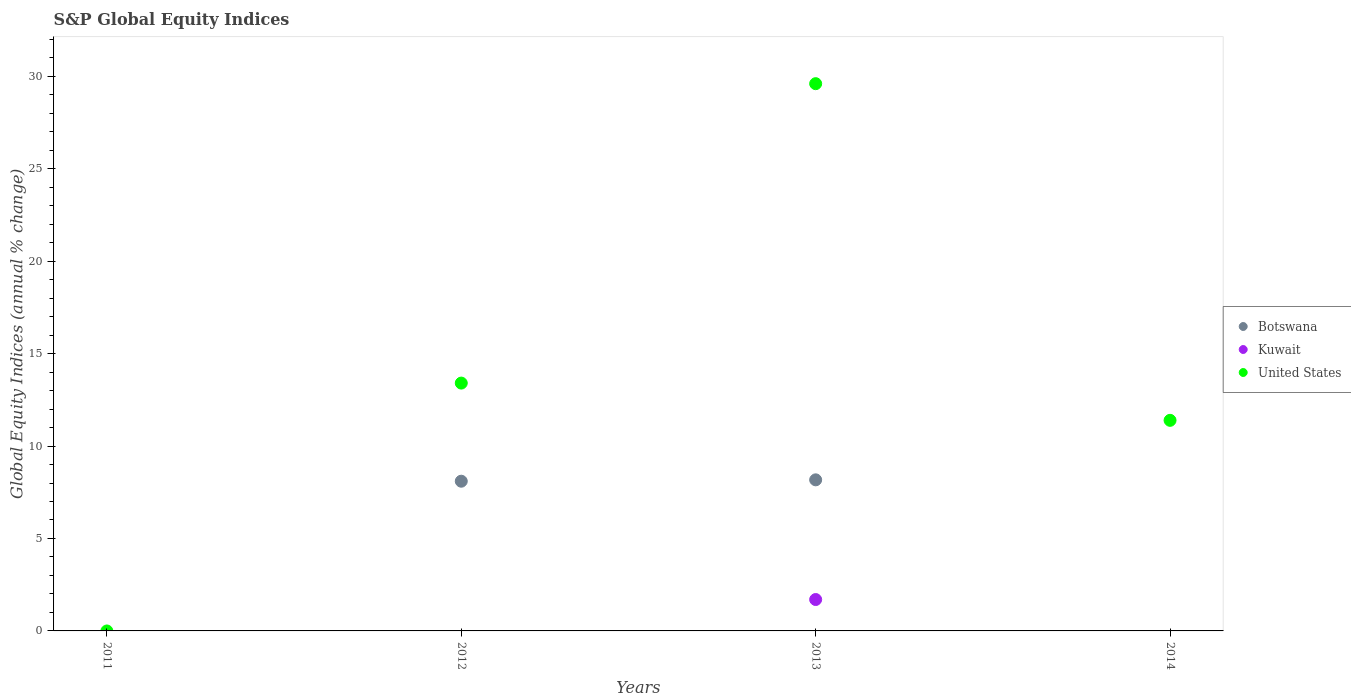Is the number of dotlines equal to the number of legend labels?
Offer a terse response. No. What is the global equity indices in Kuwait in 2013?
Offer a very short reply. 1.7. Across all years, what is the maximum global equity indices in Botswana?
Keep it short and to the point. 8.17. Across all years, what is the minimum global equity indices in United States?
Your answer should be compact. 0. What is the total global equity indices in United States in the graph?
Keep it short and to the point. 54.4. What is the difference between the global equity indices in United States in 2012 and that in 2014?
Provide a succinct answer. 2.02. What is the difference between the global equity indices in Kuwait in 2013 and the global equity indices in Botswana in 2014?
Your answer should be very brief. 1.7. What is the average global equity indices in United States per year?
Your answer should be compact. 13.6. In the year 2012, what is the difference between the global equity indices in Botswana and global equity indices in United States?
Your answer should be compact. -5.31. What is the ratio of the global equity indices in United States in 2012 to that in 2014?
Your response must be concise. 1.18. What is the difference between the highest and the second highest global equity indices in United States?
Make the answer very short. 16.2. What is the difference between the highest and the lowest global equity indices in Kuwait?
Your answer should be compact. 1.7. In how many years, is the global equity indices in Kuwait greater than the average global equity indices in Kuwait taken over all years?
Make the answer very short. 1. Is the global equity indices in Kuwait strictly less than the global equity indices in Botswana over the years?
Keep it short and to the point. Yes. How many dotlines are there?
Keep it short and to the point. 3. How many years are there in the graph?
Make the answer very short. 4. What is the title of the graph?
Offer a very short reply. S&P Global Equity Indices. Does "Swaziland" appear as one of the legend labels in the graph?
Your response must be concise. No. What is the label or title of the Y-axis?
Offer a terse response. Global Equity Indices (annual % change). What is the Global Equity Indices (annual % change) of Botswana in 2012?
Your response must be concise. 8.1. What is the Global Equity Indices (annual % change) in United States in 2012?
Your answer should be very brief. 13.41. What is the Global Equity Indices (annual % change) of Botswana in 2013?
Offer a very short reply. 8.17. What is the Global Equity Indices (annual % change) of Kuwait in 2013?
Give a very brief answer. 1.7. What is the Global Equity Indices (annual % change) of United States in 2013?
Your answer should be very brief. 29.6. What is the Global Equity Indices (annual % change) in Botswana in 2014?
Offer a very short reply. 0. What is the Global Equity Indices (annual % change) of Kuwait in 2014?
Give a very brief answer. 0. What is the Global Equity Indices (annual % change) of United States in 2014?
Offer a terse response. 11.39. Across all years, what is the maximum Global Equity Indices (annual % change) in Botswana?
Keep it short and to the point. 8.17. Across all years, what is the maximum Global Equity Indices (annual % change) of Kuwait?
Provide a short and direct response. 1.7. Across all years, what is the maximum Global Equity Indices (annual % change) of United States?
Offer a terse response. 29.6. Across all years, what is the minimum Global Equity Indices (annual % change) in Botswana?
Your response must be concise. 0. Across all years, what is the minimum Global Equity Indices (annual % change) in Kuwait?
Your answer should be compact. 0. Across all years, what is the minimum Global Equity Indices (annual % change) of United States?
Make the answer very short. 0. What is the total Global Equity Indices (annual % change) in Botswana in the graph?
Your answer should be very brief. 16.27. What is the total Global Equity Indices (annual % change) of Kuwait in the graph?
Your response must be concise. 1.7. What is the total Global Equity Indices (annual % change) of United States in the graph?
Make the answer very short. 54.4. What is the difference between the Global Equity Indices (annual % change) of Botswana in 2012 and that in 2013?
Provide a succinct answer. -0.07. What is the difference between the Global Equity Indices (annual % change) of United States in 2012 and that in 2013?
Make the answer very short. -16.2. What is the difference between the Global Equity Indices (annual % change) of United States in 2012 and that in 2014?
Give a very brief answer. 2.02. What is the difference between the Global Equity Indices (annual % change) in United States in 2013 and that in 2014?
Provide a short and direct response. 18.21. What is the difference between the Global Equity Indices (annual % change) in Botswana in 2012 and the Global Equity Indices (annual % change) in Kuwait in 2013?
Your answer should be very brief. 6.4. What is the difference between the Global Equity Indices (annual % change) in Botswana in 2012 and the Global Equity Indices (annual % change) in United States in 2013?
Your answer should be very brief. -21.5. What is the difference between the Global Equity Indices (annual % change) of Botswana in 2012 and the Global Equity Indices (annual % change) of United States in 2014?
Your answer should be very brief. -3.29. What is the difference between the Global Equity Indices (annual % change) in Botswana in 2013 and the Global Equity Indices (annual % change) in United States in 2014?
Give a very brief answer. -3.22. What is the difference between the Global Equity Indices (annual % change) of Kuwait in 2013 and the Global Equity Indices (annual % change) of United States in 2014?
Offer a terse response. -9.69. What is the average Global Equity Indices (annual % change) in Botswana per year?
Your response must be concise. 4.07. What is the average Global Equity Indices (annual % change) in Kuwait per year?
Ensure brevity in your answer.  0.42. What is the average Global Equity Indices (annual % change) in United States per year?
Make the answer very short. 13.6. In the year 2012, what is the difference between the Global Equity Indices (annual % change) of Botswana and Global Equity Indices (annual % change) of United States?
Ensure brevity in your answer.  -5.31. In the year 2013, what is the difference between the Global Equity Indices (annual % change) of Botswana and Global Equity Indices (annual % change) of Kuwait?
Offer a very short reply. 6.47. In the year 2013, what is the difference between the Global Equity Indices (annual % change) in Botswana and Global Equity Indices (annual % change) in United States?
Provide a short and direct response. -21.43. In the year 2013, what is the difference between the Global Equity Indices (annual % change) in Kuwait and Global Equity Indices (annual % change) in United States?
Your answer should be compact. -27.9. What is the ratio of the Global Equity Indices (annual % change) of Botswana in 2012 to that in 2013?
Your answer should be very brief. 0.99. What is the ratio of the Global Equity Indices (annual % change) of United States in 2012 to that in 2013?
Keep it short and to the point. 0.45. What is the ratio of the Global Equity Indices (annual % change) in United States in 2012 to that in 2014?
Give a very brief answer. 1.18. What is the ratio of the Global Equity Indices (annual % change) of United States in 2013 to that in 2014?
Your answer should be very brief. 2.6. What is the difference between the highest and the second highest Global Equity Indices (annual % change) in United States?
Your answer should be compact. 16.2. What is the difference between the highest and the lowest Global Equity Indices (annual % change) in Botswana?
Your answer should be very brief. 8.17. What is the difference between the highest and the lowest Global Equity Indices (annual % change) in Kuwait?
Keep it short and to the point. 1.7. What is the difference between the highest and the lowest Global Equity Indices (annual % change) of United States?
Provide a short and direct response. 29.6. 